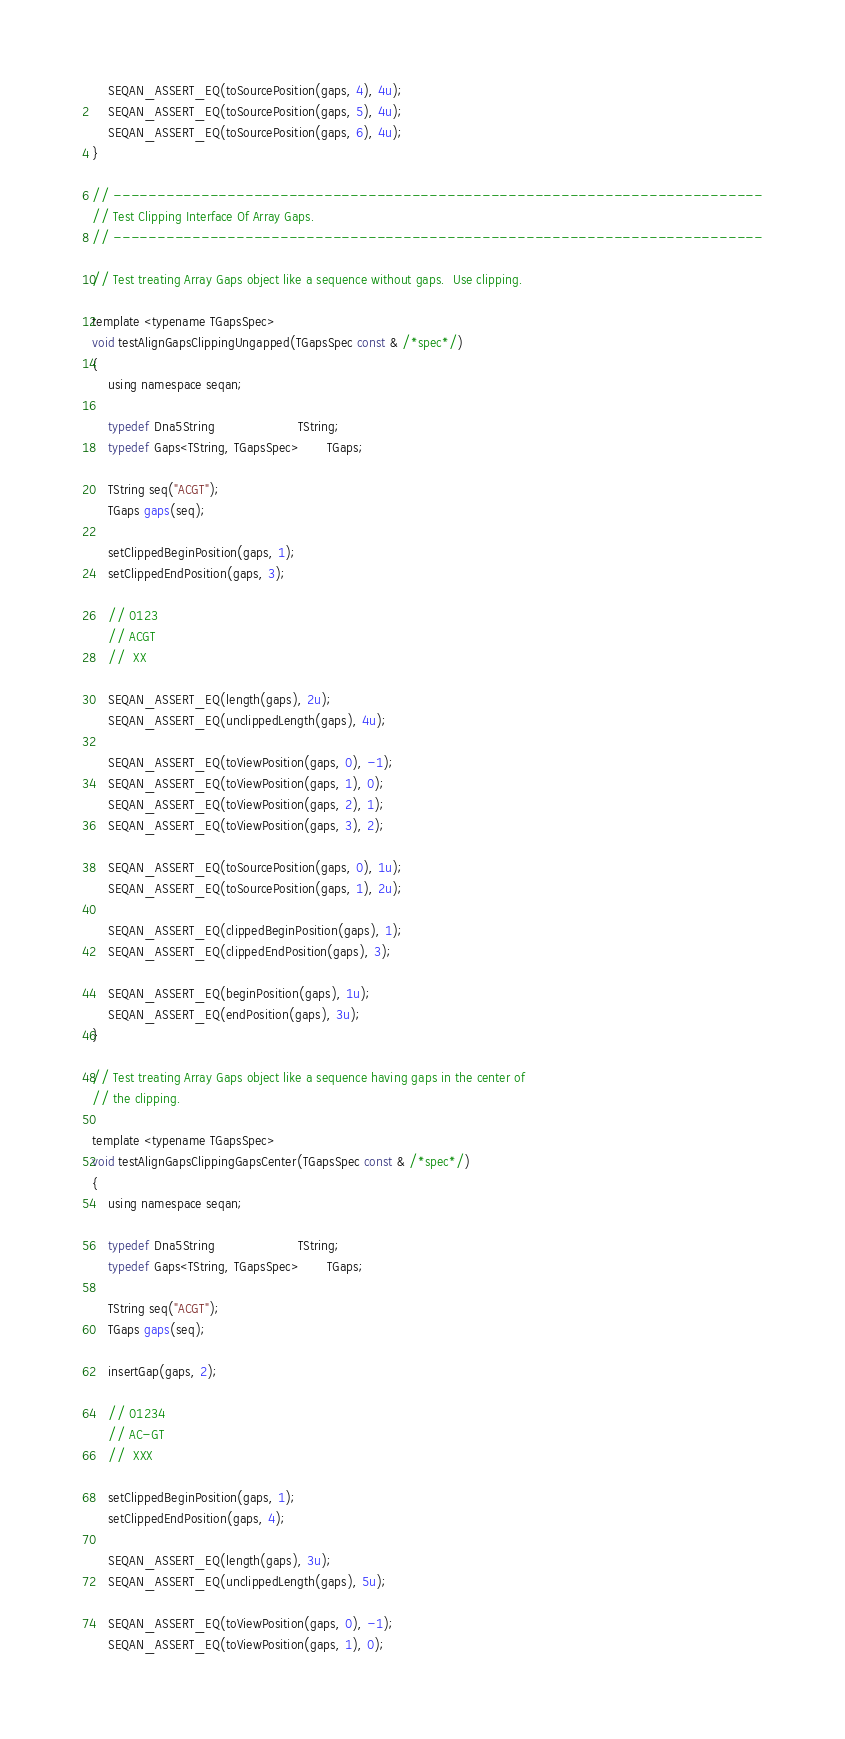<code> <loc_0><loc_0><loc_500><loc_500><_C_>    SEQAN_ASSERT_EQ(toSourcePosition(gaps, 4), 4u);
    SEQAN_ASSERT_EQ(toSourcePosition(gaps, 5), 4u);
    SEQAN_ASSERT_EQ(toSourcePosition(gaps, 6), 4u);
}

// --------------------------------------------------------------------------
// Test Clipping Interface Of Array Gaps.
// --------------------------------------------------------------------------

// Test treating Array Gaps object like a sequence without gaps.  Use clipping.

template <typename TGapsSpec>
void testAlignGapsClippingUngapped(TGapsSpec const & /*spec*/)
{
    using namespace seqan;

    typedef Dna5String                     TString;
    typedef Gaps<TString, TGapsSpec>       TGaps;

    TString seq("ACGT");
    TGaps gaps(seq);

    setClippedBeginPosition(gaps, 1);
    setClippedEndPosition(gaps, 3);

    // 0123
    // ACGT
    //  XX

    SEQAN_ASSERT_EQ(length(gaps), 2u);
    SEQAN_ASSERT_EQ(unclippedLength(gaps), 4u);

    SEQAN_ASSERT_EQ(toViewPosition(gaps, 0), -1);
    SEQAN_ASSERT_EQ(toViewPosition(gaps, 1), 0);
    SEQAN_ASSERT_EQ(toViewPosition(gaps, 2), 1);
    SEQAN_ASSERT_EQ(toViewPosition(gaps, 3), 2);

    SEQAN_ASSERT_EQ(toSourcePosition(gaps, 0), 1u);
    SEQAN_ASSERT_EQ(toSourcePosition(gaps, 1), 2u);

    SEQAN_ASSERT_EQ(clippedBeginPosition(gaps), 1);
    SEQAN_ASSERT_EQ(clippedEndPosition(gaps), 3);

    SEQAN_ASSERT_EQ(beginPosition(gaps), 1u);
    SEQAN_ASSERT_EQ(endPosition(gaps), 3u);
}

// Test treating Array Gaps object like a sequence having gaps in the center of
// the clipping.

template <typename TGapsSpec>
void testAlignGapsClippingGapsCenter(TGapsSpec const & /*spec*/)
{
    using namespace seqan;

    typedef Dna5String                     TString;
    typedef Gaps<TString, TGapsSpec>       TGaps;

    TString seq("ACGT");
    TGaps gaps(seq);

    insertGap(gaps, 2);

    // 01234
    // AC-GT
    //  XXX

    setClippedBeginPosition(gaps, 1);
    setClippedEndPosition(gaps, 4);

    SEQAN_ASSERT_EQ(length(gaps), 3u);
    SEQAN_ASSERT_EQ(unclippedLength(gaps), 5u);

    SEQAN_ASSERT_EQ(toViewPosition(gaps, 0), -1);
    SEQAN_ASSERT_EQ(toViewPosition(gaps, 1), 0);</code> 